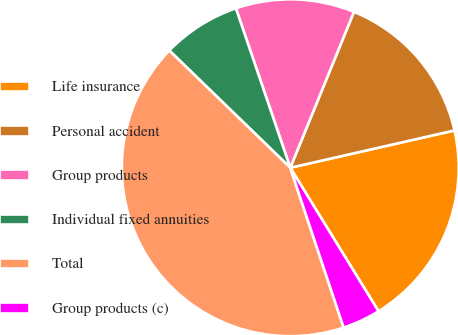Convert chart to OTSL. <chart><loc_0><loc_0><loc_500><loc_500><pie_chart><fcel>Life insurance<fcel>Personal accident<fcel>Group products<fcel>Individual fixed annuities<fcel>Total<fcel>Group products (c)<nl><fcel>19.78%<fcel>15.27%<fcel>11.4%<fcel>7.52%<fcel>42.38%<fcel>3.65%<nl></chart> 